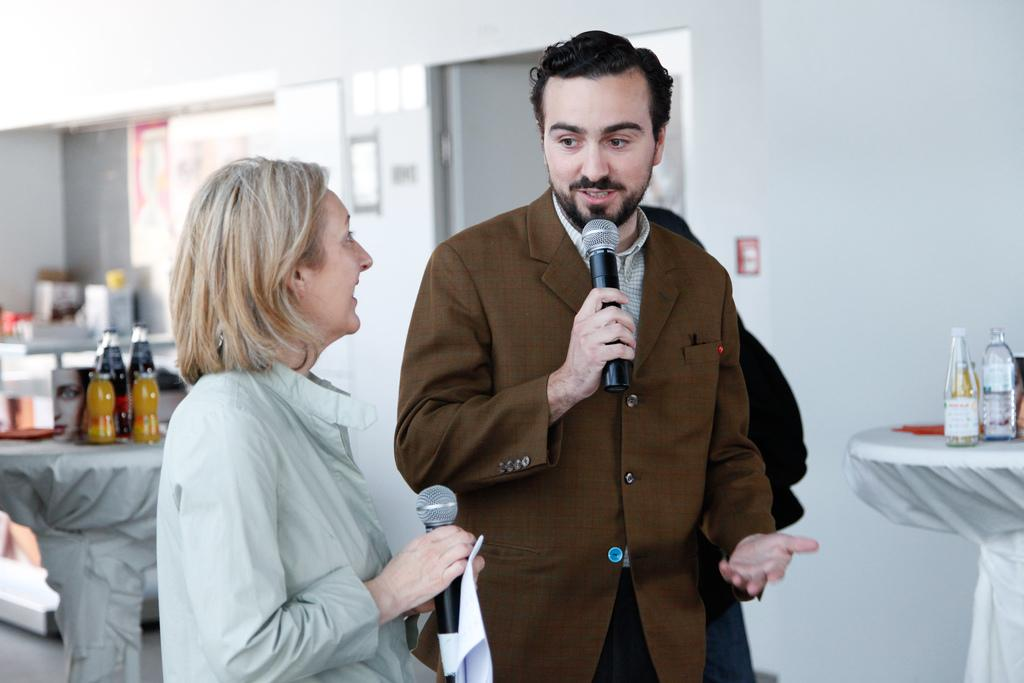What are the persons in the image doing? The persons in the image are standing and holding microphones. What objects can be seen on a table in the background? There are bottles on a table in the background. What structures are visible in the background? There is a wall and a door in the background. How much money is being exchanged between the persons in the image? There is no indication of money or any exchange of money in the image. What type of salt is being used by the persons in the image? There is no salt present in the image. 